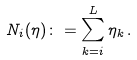Convert formula to latex. <formula><loc_0><loc_0><loc_500><loc_500>N _ { i } ( \eta ) \colon = \sum _ { k = i } ^ { L } \eta _ { k } \, .</formula> 